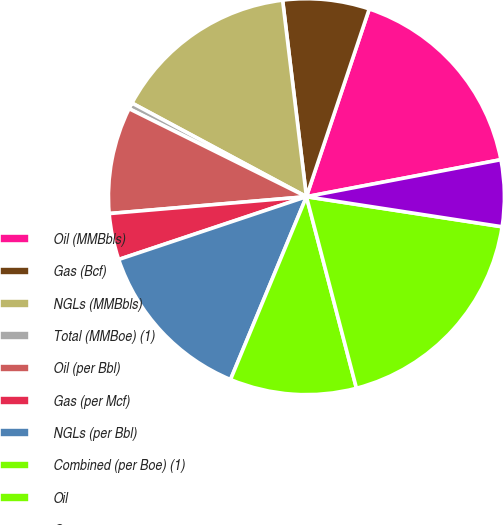<chart> <loc_0><loc_0><loc_500><loc_500><pie_chart><fcel>Oil (MMBbls)<fcel>Gas (Bcf)<fcel>NGLs (MMBbls)<fcel>Total (MMBoe) (1)<fcel>Oil (per Bbl)<fcel>Gas (per Mcf)<fcel>NGLs (per Bbl)<fcel>Combined (per Boe) (1)<fcel>Oil<fcel>Gas<nl><fcel>16.87%<fcel>7.06%<fcel>15.24%<fcel>0.51%<fcel>8.69%<fcel>3.78%<fcel>13.6%<fcel>10.33%<fcel>18.51%<fcel>5.42%<nl></chart> 